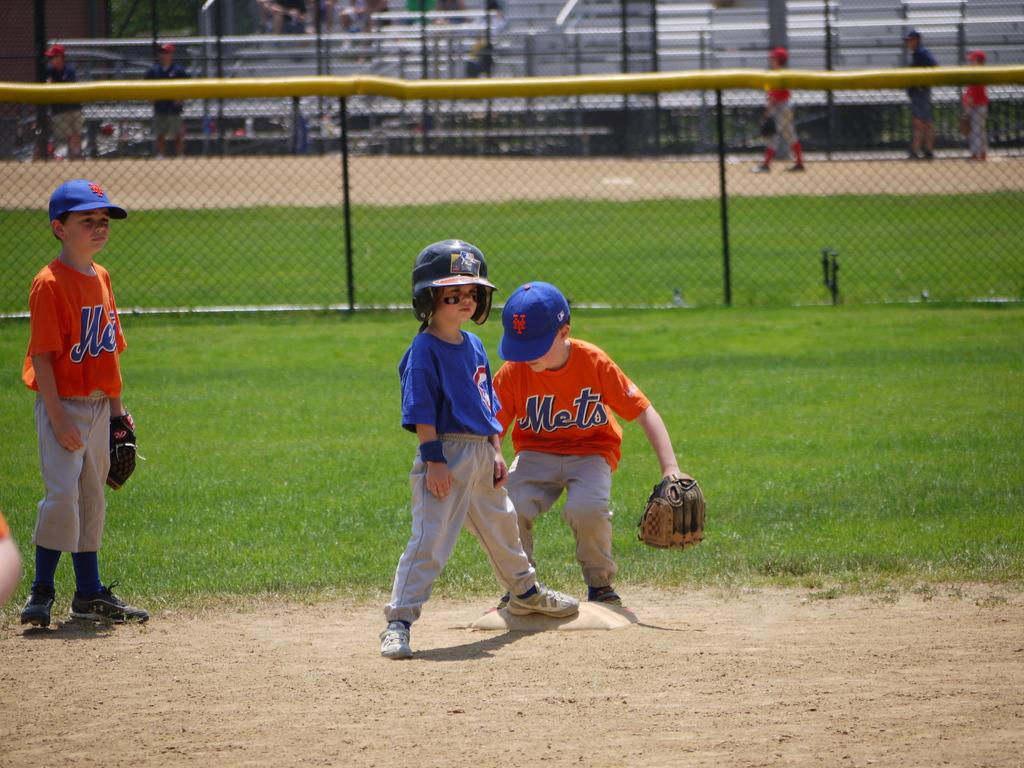<image>
Share a concise interpretation of the image provided. A Little League team competes in a game while wearing their bright orange Mets uniforms. 